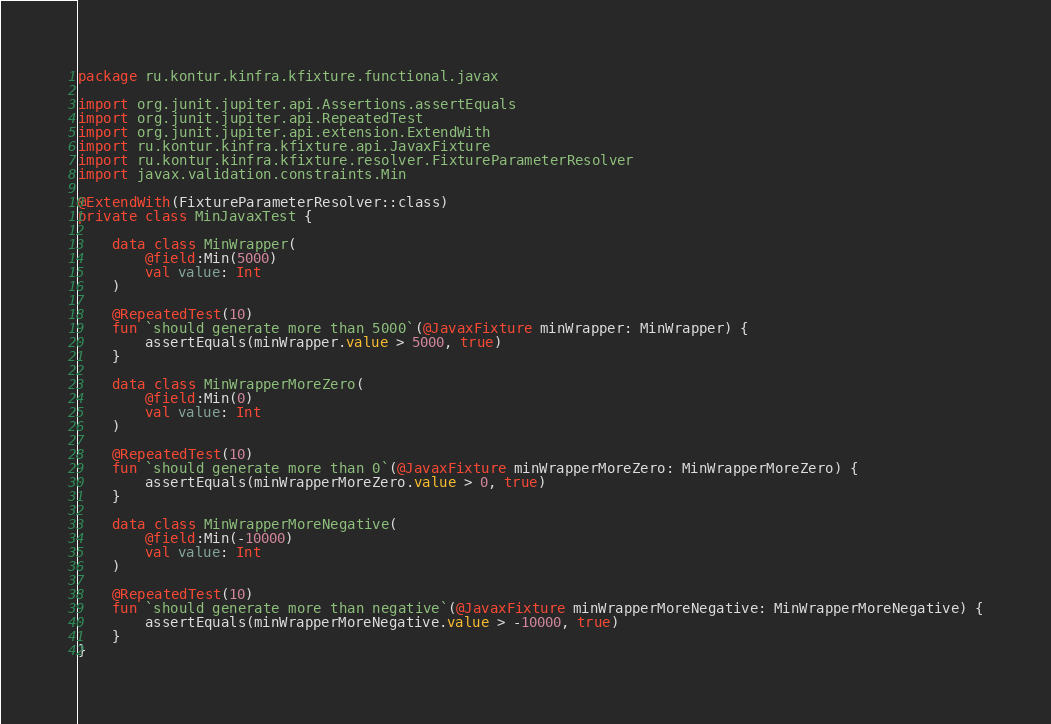Convert code to text. <code><loc_0><loc_0><loc_500><loc_500><_Kotlin_>package ru.kontur.kinfra.kfixture.functional.javax

import org.junit.jupiter.api.Assertions.assertEquals
import org.junit.jupiter.api.RepeatedTest
import org.junit.jupiter.api.extension.ExtendWith
import ru.kontur.kinfra.kfixture.api.JavaxFixture
import ru.kontur.kinfra.kfixture.resolver.FixtureParameterResolver
import javax.validation.constraints.Min

@ExtendWith(FixtureParameterResolver::class)
private class MinJavaxTest {

    data class MinWrapper(
        @field:Min(5000)
        val value: Int
    )

    @RepeatedTest(10)
    fun `should generate more than 5000`(@JavaxFixture minWrapper: MinWrapper) {
        assertEquals(minWrapper.value > 5000, true)
    }

    data class MinWrapperMoreZero(
        @field:Min(0)
        val value: Int
    )

    @RepeatedTest(10)
    fun `should generate more than 0`(@JavaxFixture minWrapperMoreZero: MinWrapperMoreZero) {
        assertEquals(minWrapperMoreZero.value > 0, true)
    }

    data class MinWrapperMoreNegative(
        @field:Min(-10000)
        val value: Int
    )

    @RepeatedTest(10)
    fun `should generate more than negative`(@JavaxFixture minWrapperMoreNegative: MinWrapperMoreNegative) {
        assertEquals(minWrapperMoreNegative.value > -10000, true)
    }
}</code> 